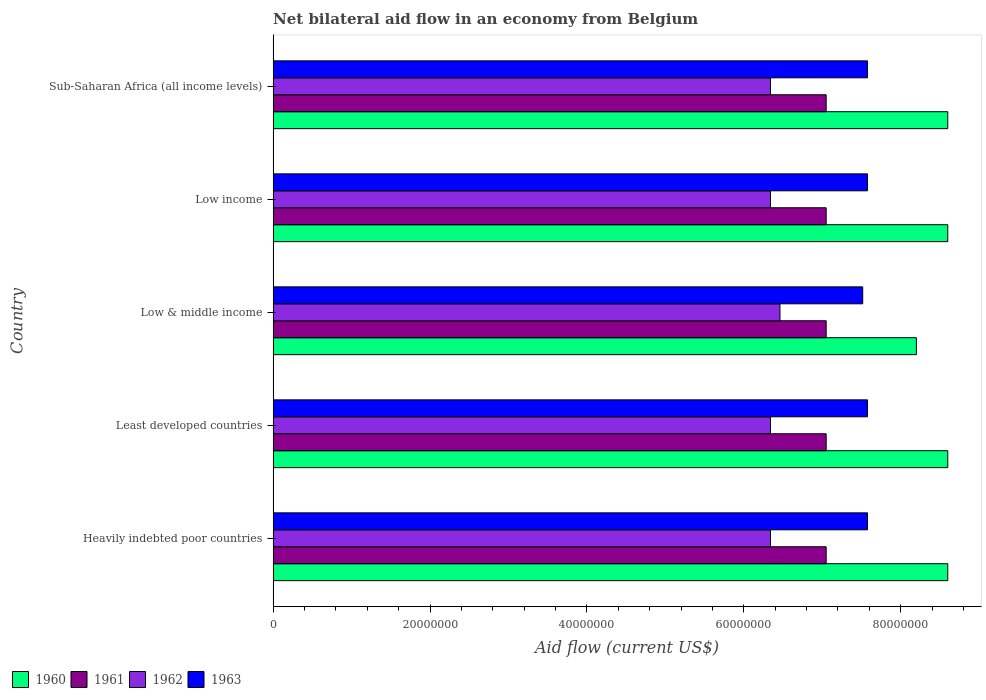How many bars are there on the 2nd tick from the top?
Provide a succinct answer. 4. In how many cases, is the number of bars for a given country not equal to the number of legend labels?
Your answer should be compact. 0. What is the net bilateral aid flow in 1962 in Sub-Saharan Africa (all income levels)?
Provide a short and direct response. 6.34e+07. Across all countries, what is the maximum net bilateral aid flow in 1961?
Your response must be concise. 7.05e+07. Across all countries, what is the minimum net bilateral aid flow in 1960?
Make the answer very short. 8.20e+07. In which country was the net bilateral aid flow in 1960 maximum?
Your answer should be very brief. Heavily indebted poor countries. In which country was the net bilateral aid flow in 1962 minimum?
Offer a very short reply. Heavily indebted poor countries. What is the total net bilateral aid flow in 1962 in the graph?
Your answer should be compact. 3.18e+08. What is the difference between the net bilateral aid flow in 1961 in Low income and that in Sub-Saharan Africa (all income levels)?
Make the answer very short. 0. What is the difference between the net bilateral aid flow in 1960 in Sub-Saharan Africa (all income levels) and the net bilateral aid flow in 1962 in Heavily indebted poor countries?
Provide a short and direct response. 2.26e+07. What is the average net bilateral aid flow in 1963 per country?
Ensure brevity in your answer.  7.56e+07. What is the difference between the net bilateral aid flow in 1963 and net bilateral aid flow in 1960 in Least developed countries?
Provide a short and direct response. -1.02e+07. What is the ratio of the net bilateral aid flow in 1960 in Heavily indebted poor countries to that in Low income?
Your answer should be compact. 1. What is the difference between the highest and the second highest net bilateral aid flow in 1963?
Your response must be concise. 0. What is the difference between the highest and the lowest net bilateral aid flow in 1960?
Your answer should be very brief. 4.00e+06. Is the sum of the net bilateral aid flow in 1962 in Least developed countries and Sub-Saharan Africa (all income levels) greater than the maximum net bilateral aid flow in 1960 across all countries?
Offer a terse response. Yes. What does the 4th bar from the top in Low income represents?
Ensure brevity in your answer.  1960. What does the 1st bar from the bottom in Sub-Saharan Africa (all income levels) represents?
Provide a short and direct response. 1960. Is it the case that in every country, the sum of the net bilateral aid flow in 1960 and net bilateral aid flow in 1961 is greater than the net bilateral aid flow in 1962?
Ensure brevity in your answer.  Yes. How many countries are there in the graph?
Make the answer very short. 5. What is the difference between two consecutive major ticks on the X-axis?
Your answer should be compact. 2.00e+07. Does the graph contain grids?
Offer a very short reply. No. Where does the legend appear in the graph?
Ensure brevity in your answer.  Bottom left. How many legend labels are there?
Your answer should be compact. 4. How are the legend labels stacked?
Your answer should be very brief. Horizontal. What is the title of the graph?
Ensure brevity in your answer.  Net bilateral aid flow in an economy from Belgium. What is the label or title of the X-axis?
Offer a very short reply. Aid flow (current US$). What is the label or title of the Y-axis?
Offer a terse response. Country. What is the Aid flow (current US$) in 1960 in Heavily indebted poor countries?
Your answer should be compact. 8.60e+07. What is the Aid flow (current US$) in 1961 in Heavily indebted poor countries?
Your answer should be very brief. 7.05e+07. What is the Aid flow (current US$) in 1962 in Heavily indebted poor countries?
Make the answer very short. 6.34e+07. What is the Aid flow (current US$) of 1963 in Heavily indebted poor countries?
Provide a succinct answer. 7.58e+07. What is the Aid flow (current US$) of 1960 in Least developed countries?
Keep it short and to the point. 8.60e+07. What is the Aid flow (current US$) of 1961 in Least developed countries?
Offer a terse response. 7.05e+07. What is the Aid flow (current US$) of 1962 in Least developed countries?
Give a very brief answer. 6.34e+07. What is the Aid flow (current US$) in 1963 in Least developed countries?
Your response must be concise. 7.58e+07. What is the Aid flow (current US$) of 1960 in Low & middle income?
Provide a short and direct response. 8.20e+07. What is the Aid flow (current US$) of 1961 in Low & middle income?
Your answer should be compact. 7.05e+07. What is the Aid flow (current US$) of 1962 in Low & middle income?
Make the answer very short. 6.46e+07. What is the Aid flow (current US$) of 1963 in Low & middle income?
Your answer should be compact. 7.52e+07. What is the Aid flow (current US$) in 1960 in Low income?
Keep it short and to the point. 8.60e+07. What is the Aid flow (current US$) of 1961 in Low income?
Make the answer very short. 7.05e+07. What is the Aid flow (current US$) of 1962 in Low income?
Your answer should be compact. 6.34e+07. What is the Aid flow (current US$) of 1963 in Low income?
Offer a terse response. 7.58e+07. What is the Aid flow (current US$) of 1960 in Sub-Saharan Africa (all income levels)?
Your answer should be very brief. 8.60e+07. What is the Aid flow (current US$) of 1961 in Sub-Saharan Africa (all income levels)?
Give a very brief answer. 7.05e+07. What is the Aid flow (current US$) in 1962 in Sub-Saharan Africa (all income levels)?
Give a very brief answer. 6.34e+07. What is the Aid flow (current US$) in 1963 in Sub-Saharan Africa (all income levels)?
Your answer should be very brief. 7.58e+07. Across all countries, what is the maximum Aid flow (current US$) in 1960?
Your answer should be compact. 8.60e+07. Across all countries, what is the maximum Aid flow (current US$) in 1961?
Your answer should be compact. 7.05e+07. Across all countries, what is the maximum Aid flow (current US$) of 1962?
Your answer should be very brief. 6.46e+07. Across all countries, what is the maximum Aid flow (current US$) of 1963?
Provide a succinct answer. 7.58e+07. Across all countries, what is the minimum Aid flow (current US$) in 1960?
Your answer should be very brief. 8.20e+07. Across all countries, what is the minimum Aid flow (current US$) of 1961?
Your answer should be compact. 7.05e+07. Across all countries, what is the minimum Aid flow (current US$) of 1962?
Your answer should be compact. 6.34e+07. Across all countries, what is the minimum Aid flow (current US$) of 1963?
Provide a succinct answer. 7.52e+07. What is the total Aid flow (current US$) of 1960 in the graph?
Make the answer very short. 4.26e+08. What is the total Aid flow (current US$) of 1961 in the graph?
Your response must be concise. 3.52e+08. What is the total Aid flow (current US$) in 1962 in the graph?
Provide a short and direct response. 3.18e+08. What is the total Aid flow (current US$) of 1963 in the graph?
Your answer should be compact. 3.78e+08. What is the difference between the Aid flow (current US$) of 1961 in Heavily indebted poor countries and that in Least developed countries?
Your answer should be very brief. 0. What is the difference between the Aid flow (current US$) of 1963 in Heavily indebted poor countries and that in Least developed countries?
Your answer should be very brief. 0. What is the difference between the Aid flow (current US$) of 1962 in Heavily indebted poor countries and that in Low & middle income?
Give a very brief answer. -1.21e+06. What is the difference between the Aid flow (current US$) of 1963 in Heavily indebted poor countries and that in Low & middle income?
Provide a short and direct response. 6.10e+05. What is the difference between the Aid flow (current US$) of 1962 in Heavily indebted poor countries and that in Low income?
Make the answer very short. 0. What is the difference between the Aid flow (current US$) in 1960 in Heavily indebted poor countries and that in Sub-Saharan Africa (all income levels)?
Your answer should be very brief. 0. What is the difference between the Aid flow (current US$) of 1961 in Heavily indebted poor countries and that in Sub-Saharan Africa (all income levels)?
Offer a terse response. 0. What is the difference between the Aid flow (current US$) of 1961 in Least developed countries and that in Low & middle income?
Provide a succinct answer. 0. What is the difference between the Aid flow (current US$) of 1962 in Least developed countries and that in Low & middle income?
Provide a succinct answer. -1.21e+06. What is the difference between the Aid flow (current US$) in 1963 in Least developed countries and that in Low & middle income?
Offer a terse response. 6.10e+05. What is the difference between the Aid flow (current US$) of 1962 in Least developed countries and that in Low income?
Make the answer very short. 0. What is the difference between the Aid flow (current US$) in 1962 in Low & middle income and that in Low income?
Offer a terse response. 1.21e+06. What is the difference between the Aid flow (current US$) of 1963 in Low & middle income and that in Low income?
Ensure brevity in your answer.  -6.10e+05. What is the difference between the Aid flow (current US$) of 1960 in Low & middle income and that in Sub-Saharan Africa (all income levels)?
Offer a terse response. -4.00e+06. What is the difference between the Aid flow (current US$) in 1961 in Low & middle income and that in Sub-Saharan Africa (all income levels)?
Your answer should be compact. 0. What is the difference between the Aid flow (current US$) in 1962 in Low & middle income and that in Sub-Saharan Africa (all income levels)?
Give a very brief answer. 1.21e+06. What is the difference between the Aid flow (current US$) of 1963 in Low & middle income and that in Sub-Saharan Africa (all income levels)?
Provide a short and direct response. -6.10e+05. What is the difference between the Aid flow (current US$) in 1960 in Low income and that in Sub-Saharan Africa (all income levels)?
Give a very brief answer. 0. What is the difference between the Aid flow (current US$) of 1961 in Low income and that in Sub-Saharan Africa (all income levels)?
Your answer should be compact. 0. What is the difference between the Aid flow (current US$) in 1963 in Low income and that in Sub-Saharan Africa (all income levels)?
Provide a short and direct response. 0. What is the difference between the Aid flow (current US$) in 1960 in Heavily indebted poor countries and the Aid flow (current US$) in 1961 in Least developed countries?
Keep it short and to the point. 1.55e+07. What is the difference between the Aid flow (current US$) of 1960 in Heavily indebted poor countries and the Aid flow (current US$) of 1962 in Least developed countries?
Your answer should be very brief. 2.26e+07. What is the difference between the Aid flow (current US$) in 1960 in Heavily indebted poor countries and the Aid flow (current US$) in 1963 in Least developed countries?
Provide a succinct answer. 1.02e+07. What is the difference between the Aid flow (current US$) in 1961 in Heavily indebted poor countries and the Aid flow (current US$) in 1962 in Least developed countries?
Your response must be concise. 7.10e+06. What is the difference between the Aid flow (current US$) in 1961 in Heavily indebted poor countries and the Aid flow (current US$) in 1963 in Least developed countries?
Your answer should be compact. -5.27e+06. What is the difference between the Aid flow (current US$) in 1962 in Heavily indebted poor countries and the Aid flow (current US$) in 1963 in Least developed countries?
Provide a short and direct response. -1.24e+07. What is the difference between the Aid flow (current US$) of 1960 in Heavily indebted poor countries and the Aid flow (current US$) of 1961 in Low & middle income?
Provide a succinct answer. 1.55e+07. What is the difference between the Aid flow (current US$) in 1960 in Heavily indebted poor countries and the Aid flow (current US$) in 1962 in Low & middle income?
Provide a short and direct response. 2.14e+07. What is the difference between the Aid flow (current US$) in 1960 in Heavily indebted poor countries and the Aid flow (current US$) in 1963 in Low & middle income?
Offer a very short reply. 1.08e+07. What is the difference between the Aid flow (current US$) of 1961 in Heavily indebted poor countries and the Aid flow (current US$) of 1962 in Low & middle income?
Your answer should be compact. 5.89e+06. What is the difference between the Aid flow (current US$) of 1961 in Heavily indebted poor countries and the Aid flow (current US$) of 1963 in Low & middle income?
Give a very brief answer. -4.66e+06. What is the difference between the Aid flow (current US$) of 1962 in Heavily indebted poor countries and the Aid flow (current US$) of 1963 in Low & middle income?
Your answer should be compact. -1.18e+07. What is the difference between the Aid flow (current US$) of 1960 in Heavily indebted poor countries and the Aid flow (current US$) of 1961 in Low income?
Offer a terse response. 1.55e+07. What is the difference between the Aid flow (current US$) of 1960 in Heavily indebted poor countries and the Aid flow (current US$) of 1962 in Low income?
Make the answer very short. 2.26e+07. What is the difference between the Aid flow (current US$) in 1960 in Heavily indebted poor countries and the Aid flow (current US$) in 1963 in Low income?
Your answer should be compact. 1.02e+07. What is the difference between the Aid flow (current US$) in 1961 in Heavily indebted poor countries and the Aid flow (current US$) in 1962 in Low income?
Offer a terse response. 7.10e+06. What is the difference between the Aid flow (current US$) of 1961 in Heavily indebted poor countries and the Aid flow (current US$) of 1963 in Low income?
Provide a succinct answer. -5.27e+06. What is the difference between the Aid flow (current US$) of 1962 in Heavily indebted poor countries and the Aid flow (current US$) of 1963 in Low income?
Give a very brief answer. -1.24e+07. What is the difference between the Aid flow (current US$) in 1960 in Heavily indebted poor countries and the Aid flow (current US$) in 1961 in Sub-Saharan Africa (all income levels)?
Your answer should be compact. 1.55e+07. What is the difference between the Aid flow (current US$) of 1960 in Heavily indebted poor countries and the Aid flow (current US$) of 1962 in Sub-Saharan Africa (all income levels)?
Your answer should be compact. 2.26e+07. What is the difference between the Aid flow (current US$) in 1960 in Heavily indebted poor countries and the Aid flow (current US$) in 1963 in Sub-Saharan Africa (all income levels)?
Provide a succinct answer. 1.02e+07. What is the difference between the Aid flow (current US$) of 1961 in Heavily indebted poor countries and the Aid flow (current US$) of 1962 in Sub-Saharan Africa (all income levels)?
Offer a very short reply. 7.10e+06. What is the difference between the Aid flow (current US$) of 1961 in Heavily indebted poor countries and the Aid flow (current US$) of 1963 in Sub-Saharan Africa (all income levels)?
Provide a short and direct response. -5.27e+06. What is the difference between the Aid flow (current US$) in 1962 in Heavily indebted poor countries and the Aid flow (current US$) in 1963 in Sub-Saharan Africa (all income levels)?
Offer a terse response. -1.24e+07. What is the difference between the Aid flow (current US$) of 1960 in Least developed countries and the Aid flow (current US$) of 1961 in Low & middle income?
Offer a very short reply. 1.55e+07. What is the difference between the Aid flow (current US$) of 1960 in Least developed countries and the Aid flow (current US$) of 1962 in Low & middle income?
Your answer should be compact. 2.14e+07. What is the difference between the Aid flow (current US$) in 1960 in Least developed countries and the Aid flow (current US$) in 1963 in Low & middle income?
Provide a succinct answer. 1.08e+07. What is the difference between the Aid flow (current US$) of 1961 in Least developed countries and the Aid flow (current US$) of 1962 in Low & middle income?
Give a very brief answer. 5.89e+06. What is the difference between the Aid flow (current US$) of 1961 in Least developed countries and the Aid flow (current US$) of 1963 in Low & middle income?
Keep it short and to the point. -4.66e+06. What is the difference between the Aid flow (current US$) in 1962 in Least developed countries and the Aid flow (current US$) in 1963 in Low & middle income?
Ensure brevity in your answer.  -1.18e+07. What is the difference between the Aid flow (current US$) of 1960 in Least developed countries and the Aid flow (current US$) of 1961 in Low income?
Your answer should be very brief. 1.55e+07. What is the difference between the Aid flow (current US$) of 1960 in Least developed countries and the Aid flow (current US$) of 1962 in Low income?
Your answer should be very brief. 2.26e+07. What is the difference between the Aid flow (current US$) in 1960 in Least developed countries and the Aid flow (current US$) in 1963 in Low income?
Provide a short and direct response. 1.02e+07. What is the difference between the Aid flow (current US$) of 1961 in Least developed countries and the Aid flow (current US$) of 1962 in Low income?
Your answer should be compact. 7.10e+06. What is the difference between the Aid flow (current US$) in 1961 in Least developed countries and the Aid flow (current US$) in 1963 in Low income?
Your response must be concise. -5.27e+06. What is the difference between the Aid flow (current US$) of 1962 in Least developed countries and the Aid flow (current US$) of 1963 in Low income?
Give a very brief answer. -1.24e+07. What is the difference between the Aid flow (current US$) of 1960 in Least developed countries and the Aid flow (current US$) of 1961 in Sub-Saharan Africa (all income levels)?
Your response must be concise. 1.55e+07. What is the difference between the Aid flow (current US$) in 1960 in Least developed countries and the Aid flow (current US$) in 1962 in Sub-Saharan Africa (all income levels)?
Provide a short and direct response. 2.26e+07. What is the difference between the Aid flow (current US$) of 1960 in Least developed countries and the Aid flow (current US$) of 1963 in Sub-Saharan Africa (all income levels)?
Make the answer very short. 1.02e+07. What is the difference between the Aid flow (current US$) of 1961 in Least developed countries and the Aid flow (current US$) of 1962 in Sub-Saharan Africa (all income levels)?
Your answer should be compact. 7.10e+06. What is the difference between the Aid flow (current US$) in 1961 in Least developed countries and the Aid flow (current US$) in 1963 in Sub-Saharan Africa (all income levels)?
Your response must be concise. -5.27e+06. What is the difference between the Aid flow (current US$) of 1962 in Least developed countries and the Aid flow (current US$) of 1963 in Sub-Saharan Africa (all income levels)?
Offer a very short reply. -1.24e+07. What is the difference between the Aid flow (current US$) of 1960 in Low & middle income and the Aid flow (current US$) of 1961 in Low income?
Make the answer very short. 1.15e+07. What is the difference between the Aid flow (current US$) of 1960 in Low & middle income and the Aid flow (current US$) of 1962 in Low income?
Provide a short and direct response. 1.86e+07. What is the difference between the Aid flow (current US$) of 1960 in Low & middle income and the Aid flow (current US$) of 1963 in Low income?
Keep it short and to the point. 6.23e+06. What is the difference between the Aid flow (current US$) in 1961 in Low & middle income and the Aid flow (current US$) in 1962 in Low income?
Make the answer very short. 7.10e+06. What is the difference between the Aid flow (current US$) in 1961 in Low & middle income and the Aid flow (current US$) in 1963 in Low income?
Your answer should be compact. -5.27e+06. What is the difference between the Aid flow (current US$) of 1962 in Low & middle income and the Aid flow (current US$) of 1963 in Low income?
Your answer should be compact. -1.12e+07. What is the difference between the Aid flow (current US$) in 1960 in Low & middle income and the Aid flow (current US$) in 1961 in Sub-Saharan Africa (all income levels)?
Offer a very short reply. 1.15e+07. What is the difference between the Aid flow (current US$) in 1960 in Low & middle income and the Aid flow (current US$) in 1962 in Sub-Saharan Africa (all income levels)?
Make the answer very short. 1.86e+07. What is the difference between the Aid flow (current US$) in 1960 in Low & middle income and the Aid flow (current US$) in 1963 in Sub-Saharan Africa (all income levels)?
Provide a succinct answer. 6.23e+06. What is the difference between the Aid flow (current US$) of 1961 in Low & middle income and the Aid flow (current US$) of 1962 in Sub-Saharan Africa (all income levels)?
Keep it short and to the point. 7.10e+06. What is the difference between the Aid flow (current US$) of 1961 in Low & middle income and the Aid flow (current US$) of 1963 in Sub-Saharan Africa (all income levels)?
Your response must be concise. -5.27e+06. What is the difference between the Aid flow (current US$) in 1962 in Low & middle income and the Aid flow (current US$) in 1963 in Sub-Saharan Africa (all income levels)?
Give a very brief answer. -1.12e+07. What is the difference between the Aid flow (current US$) in 1960 in Low income and the Aid flow (current US$) in 1961 in Sub-Saharan Africa (all income levels)?
Offer a terse response. 1.55e+07. What is the difference between the Aid flow (current US$) of 1960 in Low income and the Aid flow (current US$) of 1962 in Sub-Saharan Africa (all income levels)?
Offer a very short reply. 2.26e+07. What is the difference between the Aid flow (current US$) in 1960 in Low income and the Aid flow (current US$) in 1963 in Sub-Saharan Africa (all income levels)?
Offer a terse response. 1.02e+07. What is the difference between the Aid flow (current US$) of 1961 in Low income and the Aid flow (current US$) of 1962 in Sub-Saharan Africa (all income levels)?
Your response must be concise. 7.10e+06. What is the difference between the Aid flow (current US$) in 1961 in Low income and the Aid flow (current US$) in 1963 in Sub-Saharan Africa (all income levels)?
Ensure brevity in your answer.  -5.27e+06. What is the difference between the Aid flow (current US$) in 1962 in Low income and the Aid flow (current US$) in 1963 in Sub-Saharan Africa (all income levels)?
Keep it short and to the point. -1.24e+07. What is the average Aid flow (current US$) of 1960 per country?
Offer a very short reply. 8.52e+07. What is the average Aid flow (current US$) of 1961 per country?
Provide a short and direct response. 7.05e+07. What is the average Aid flow (current US$) in 1962 per country?
Provide a succinct answer. 6.36e+07. What is the average Aid flow (current US$) of 1963 per country?
Your answer should be very brief. 7.56e+07. What is the difference between the Aid flow (current US$) in 1960 and Aid flow (current US$) in 1961 in Heavily indebted poor countries?
Ensure brevity in your answer.  1.55e+07. What is the difference between the Aid flow (current US$) in 1960 and Aid flow (current US$) in 1962 in Heavily indebted poor countries?
Offer a terse response. 2.26e+07. What is the difference between the Aid flow (current US$) of 1960 and Aid flow (current US$) of 1963 in Heavily indebted poor countries?
Your answer should be very brief. 1.02e+07. What is the difference between the Aid flow (current US$) of 1961 and Aid flow (current US$) of 1962 in Heavily indebted poor countries?
Provide a short and direct response. 7.10e+06. What is the difference between the Aid flow (current US$) in 1961 and Aid flow (current US$) in 1963 in Heavily indebted poor countries?
Keep it short and to the point. -5.27e+06. What is the difference between the Aid flow (current US$) of 1962 and Aid flow (current US$) of 1963 in Heavily indebted poor countries?
Your response must be concise. -1.24e+07. What is the difference between the Aid flow (current US$) of 1960 and Aid flow (current US$) of 1961 in Least developed countries?
Offer a terse response. 1.55e+07. What is the difference between the Aid flow (current US$) in 1960 and Aid flow (current US$) in 1962 in Least developed countries?
Offer a terse response. 2.26e+07. What is the difference between the Aid flow (current US$) of 1960 and Aid flow (current US$) of 1963 in Least developed countries?
Make the answer very short. 1.02e+07. What is the difference between the Aid flow (current US$) in 1961 and Aid flow (current US$) in 1962 in Least developed countries?
Your response must be concise. 7.10e+06. What is the difference between the Aid flow (current US$) in 1961 and Aid flow (current US$) in 1963 in Least developed countries?
Provide a short and direct response. -5.27e+06. What is the difference between the Aid flow (current US$) of 1962 and Aid flow (current US$) of 1963 in Least developed countries?
Provide a short and direct response. -1.24e+07. What is the difference between the Aid flow (current US$) in 1960 and Aid flow (current US$) in 1961 in Low & middle income?
Make the answer very short. 1.15e+07. What is the difference between the Aid flow (current US$) of 1960 and Aid flow (current US$) of 1962 in Low & middle income?
Your response must be concise. 1.74e+07. What is the difference between the Aid flow (current US$) of 1960 and Aid flow (current US$) of 1963 in Low & middle income?
Your response must be concise. 6.84e+06. What is the difference between the Aid flow (current US$) in 1961 and Aid flow (current US$) in 1962 in Low & middle income?
Keep it short and to the point. 5.89e+06. What is the difference between the Aid flow (current US$) of 1961 and Aid flow (current US$) of 1963 in Low & middle income?
Provide a succinct answer. -4.66e+06. What is the difference between the Aid flow (current US$) of 1962 and Aid flow (current US$) of 1963 in Low & middle income?
Your answer should be very brief. -1.06e+07. What is the difference between the Aid flow (current US$) in 1960 and Aid flow (current US$) in 1961 in Low income?
Provide a succinct answer. 1.55e+07. What is the difference between the Aid flow (current US$) in 1960 and Aid flow (current US$) in 1962 in Low income?
Your answer should be compact. 2.26e+07. What is the difference between the Aid flow (current US$) in 1960 and Aid flow (current US$) in 1963 in Low income?
Keep it short and to the point. 1.02e+07. What is the difference between the Aid flow (current US$) of 1961 and Aid flow (current US$) of 1962 in Low income?
Provide a short and direct response. 7.10e+06. What is the difference between the Aid flow (current US$) of 1961 and Aid flow (current US$) of 1963 in Low income?
Offer a very short reply. -5.27e+06. What is the difference between the Aid flow (current US$) of 1962 and Aid flow (current US$) of 1963 in Low income?
Make the answer very short. -1.24e+07. What is the difference between the Aid flow (current US$) of 1960 and Aid flow (current US$) of 1961 in Sub-Saharan Africa (all income levels)?
Ensure brevity in your answer.  1.55e+07. What is the difference between the Aid flow (current US$) of 1960 and Aid flow (current US$) of 1962 in Sub-Saharan Africa (all income levels)?
Your answer should be compact. 2.26e+07. What is the difference between the Aid flow (current US$) of 1960 and Aid flow (current US$) of 1963 in Sub-Saharan Africa (all income levels)?
Offer a terse response. 1.02e+07. What is the difference between the Aid flow (current US$) in 1961 and Aid flow (current US$) in 1962 in Sub-Saharan Africa (all income levels)?
Offer a terse response. 7.10e+06. What is the difference between the Aid flow (current US$) of 1961 and Aid flow (current US$) of 1963 in Sub-Saharan Africa (all income levels)?
Provide a short and direct response. -5.27e+06. What is the difference between the Aid flow (current US$) of 1962 and Aid flow (current US$) of 1963 in Sub-Saharan Africa (all income levels)?
Provide a succinct answer. -1.24e+07. What is the ratio of the Aid flow (current US$) of 1961 in Heavily indebted poor countries to that in Least developed countries?
Your answer should be very brief. 1. What is the ratio of the Aid flow (current US$) in 1963 in Heavily indebted poor countries to that in Least developed countries?
Keep it short and to the point. 1. What is the ratio of the Aid flow (current US$) of 1960 in Heavily indebted poor countries to that in Low & middle income?
Ensure brevity in your answer.  1.05. What is the ratio of the Aid flow (current US$) in 1962 in Heavily indebted poor countries to that in Low & middle income?
Your answer should be compact. 0.98. What is the ratio of the Aid flow (current US$) of 1963 in Heavily indebted poor countries to that in Low & middle income?
Give a very brief answer. 1.01. What is the ratio of the Aid flow (current US$) in 1962 in Heavily indebted poor countries to that in Low income?
Keep it short and to the point. 1. What is the ratio of the Aid flow (current US$) in 1960 in Heavily indebted poor countries to that in Sub-Saharan Africa (all income levels)?
Give a very brief answer. 1. What is the ratio of the Aid flow (current US$) of 1961 in Heavily indebted poor countries to that in Sub-Saharan Africa (all income levels)?
Give a very brief answer. 1. What is the ratio of the Aid flow (current US$) in 1963 in Heavily indebted poor countries to that in Sub-Saharan Africa (all income levels)?
Your answer should be very brief. 1. What is the ratio of the Aid flow (current US$) of 1960 in Least developed countries to that in Low & middle income?
Give a very brief answer. 1.05. What is the ratio of the Aid flow (current US$) in 1962 in Least developed countries to that in Low & middle income?
Your answer should be very brief. 0.98. What is the ratio of the Aid flow (current US$) of 1960 in Least developed countries to that in Low income?
Your answer should be very brief. 1. What is the ratio of the Aid flow (current US$) in 1961 in Least developed countries to that in Low income?
Offer a terse response. 1. What is the ratio of the Aid flow (current US$) of 1962 in Least developed countries to that in Low income?
Give a very brief answer. 1. What is the ratio of the Aid flow (current US$) in 1963 in Least developed countries to that in Low income?
Give a very brief answer. 1. What is the ratio of the Aid flow (current US$) of 1963 in Least developed countries to that in Sub-Saharan Africa (all income levels)?
Ensure brevity in your answer.  1. What is the ratio of the Aid flow (current US$) of 1960 in Low & middle income to that in Low income?
Ensure brevity in your answer.  0.95. What is the ratio of the Aid flow (current US$) in 1961 in Low & middle income to that in Low income?
Provide a succinct answer. 1. What is the ratio of the Aid flow (current US$) of 1962 in Low & middle income to that in Low income?
Keep it short and to the point. 1.02. What is the ratio of the Aid flow (current US$) of 1963 in Low & middle income to that in Low income?
Make the answer very short. 0.99. What is the ratio of the Aid flow (current US$) of 1960 in Low & middle income to that in Sub-Saharan Africa (all income levels)?
Make the answer very short. 0.95. What is the ratio of the Aid flow (current US$) in 1962 in Low & middle income to that in Sub-Saharan Africa (all income levels)?
Make the answer very short. 1.02. What is the ratio of the Aid flow (current US$) in 1960 in Low income to that in Sub-Saharan Africa (all income levels)?
Provide a short and direct response. 1. What is the ratio of the Aid flow (current US$) of 1962 in Low income to that in Sub-Saharan Africa (all income levels)?
Offer a terse response. 1. What is the difference between the highest and the second highest Aid flow (current US$) of 1961?
Make the answer very short. 0. What is the difference between the highest and the second highest Aid flow (current US$) in 1962?
Offer a very short reply. 1.21e+06. What is the difference between the highest and the lowest Aid flow (current US$) in 1960?
Ensure brevity in your answer.  4.00e+06. What is the difference between the highest and the lowest Aid flow (current US$) of 1962?
Make the answer very short. 1.21e+06. 